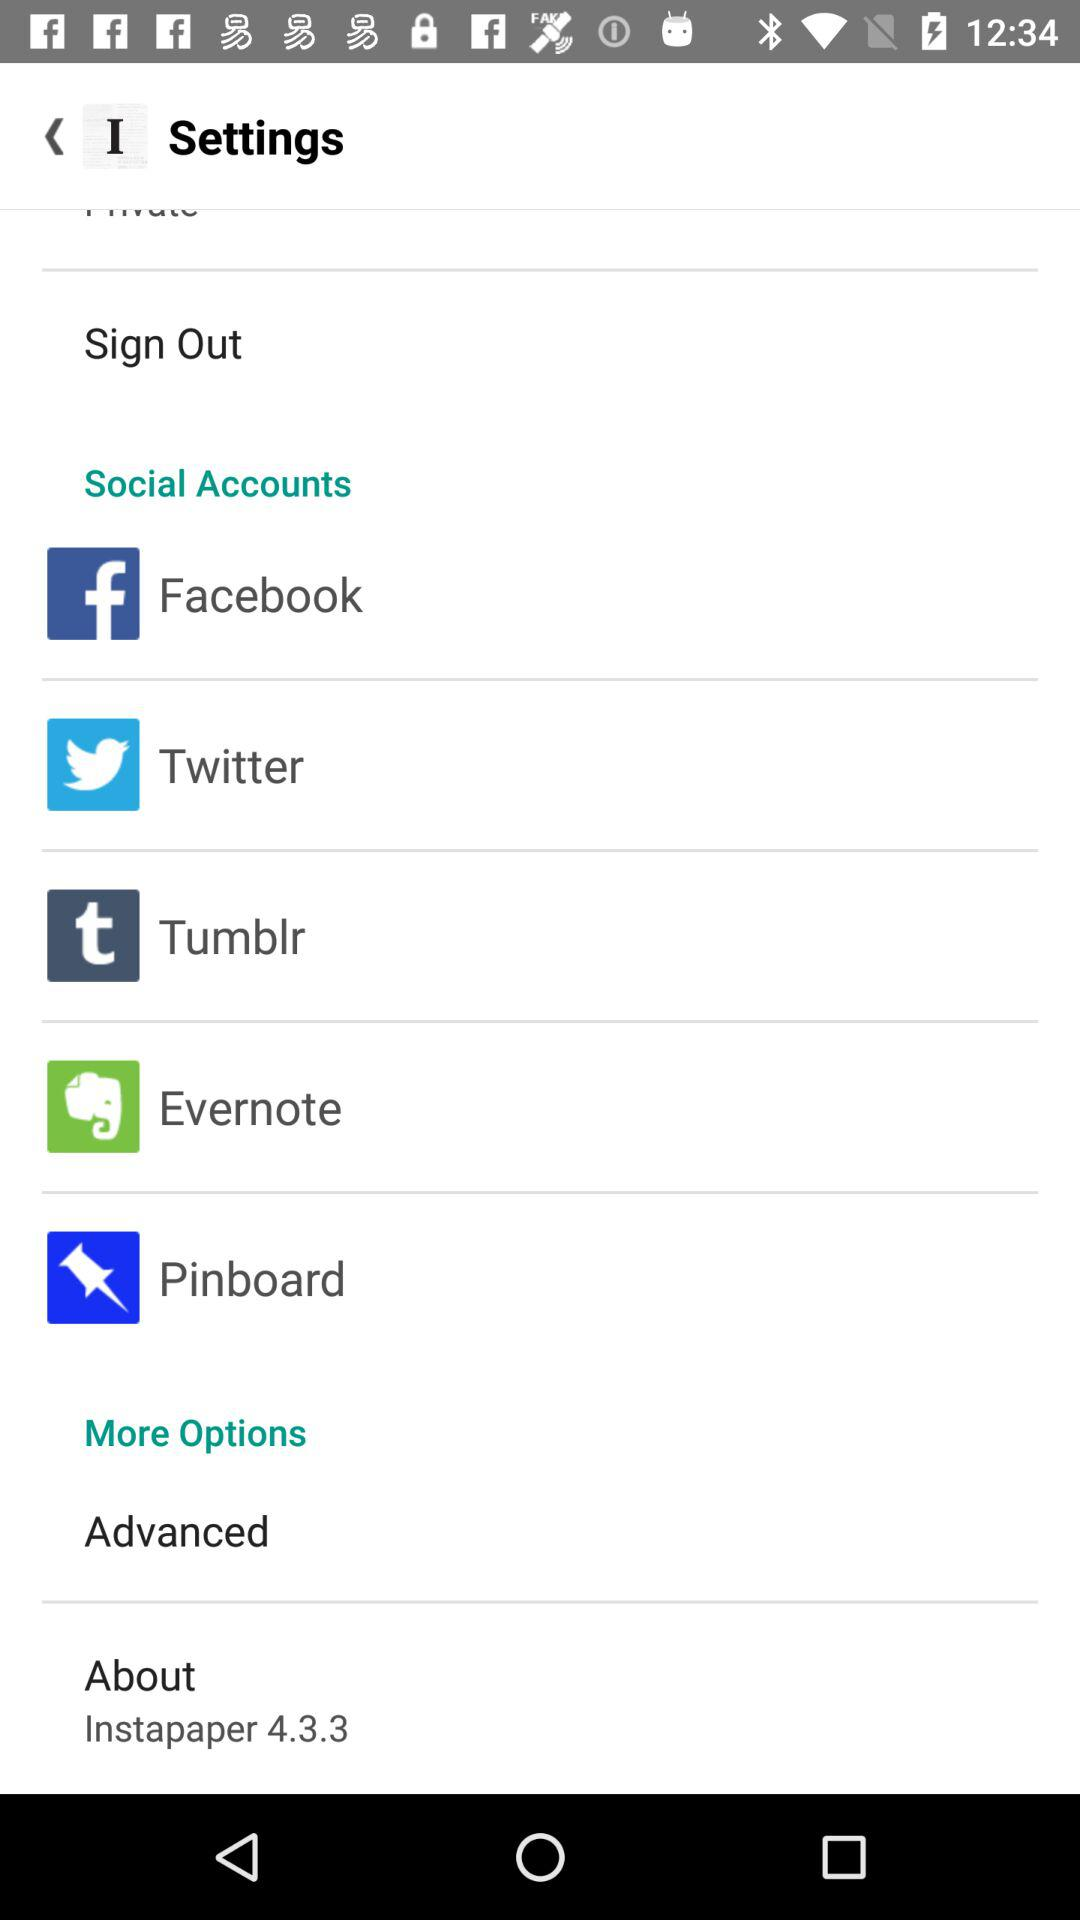Which social accounts are available? The social accounts available are "Facebook", "Twitter", "Tumblr", "Evernote" and "Pinboard". 